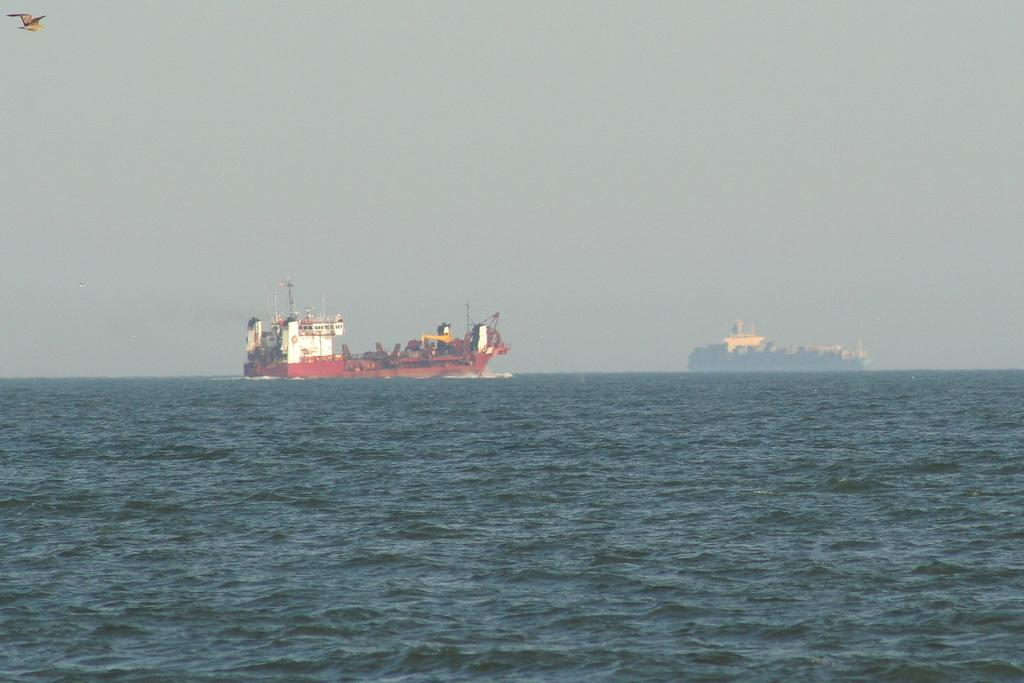What is the main subject of the image? The main subject of the image is two ships. What is the setting in which the ships are located? The ships are sailing on the sea. Can you identify any other living creature in the image? Yes, there is a bird in the top left corner of the image. What type of horn can be seen being played by the bird in the image? There is no horn present in the image, and the bird is not playing any instrument. What type of oatmeal is being served on the ships in the image? There is no oatmeal visible in the image, and it is not mentioned that any food is being served on the ships. 